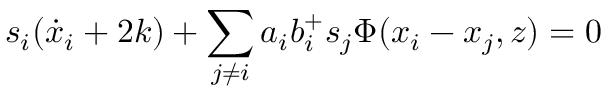Convert formula to latex. <formula><loc_0><loc_0><loc_500><loc_500>s _ { i } ( \dot { x } _ { i } + 2 k ) + \sum _ { j \neq i } a _ { i } b _ { i } ^ { + } s _ { j } \Phi ( x _ { i } - x _ { j } , z ) = 0</formula> 